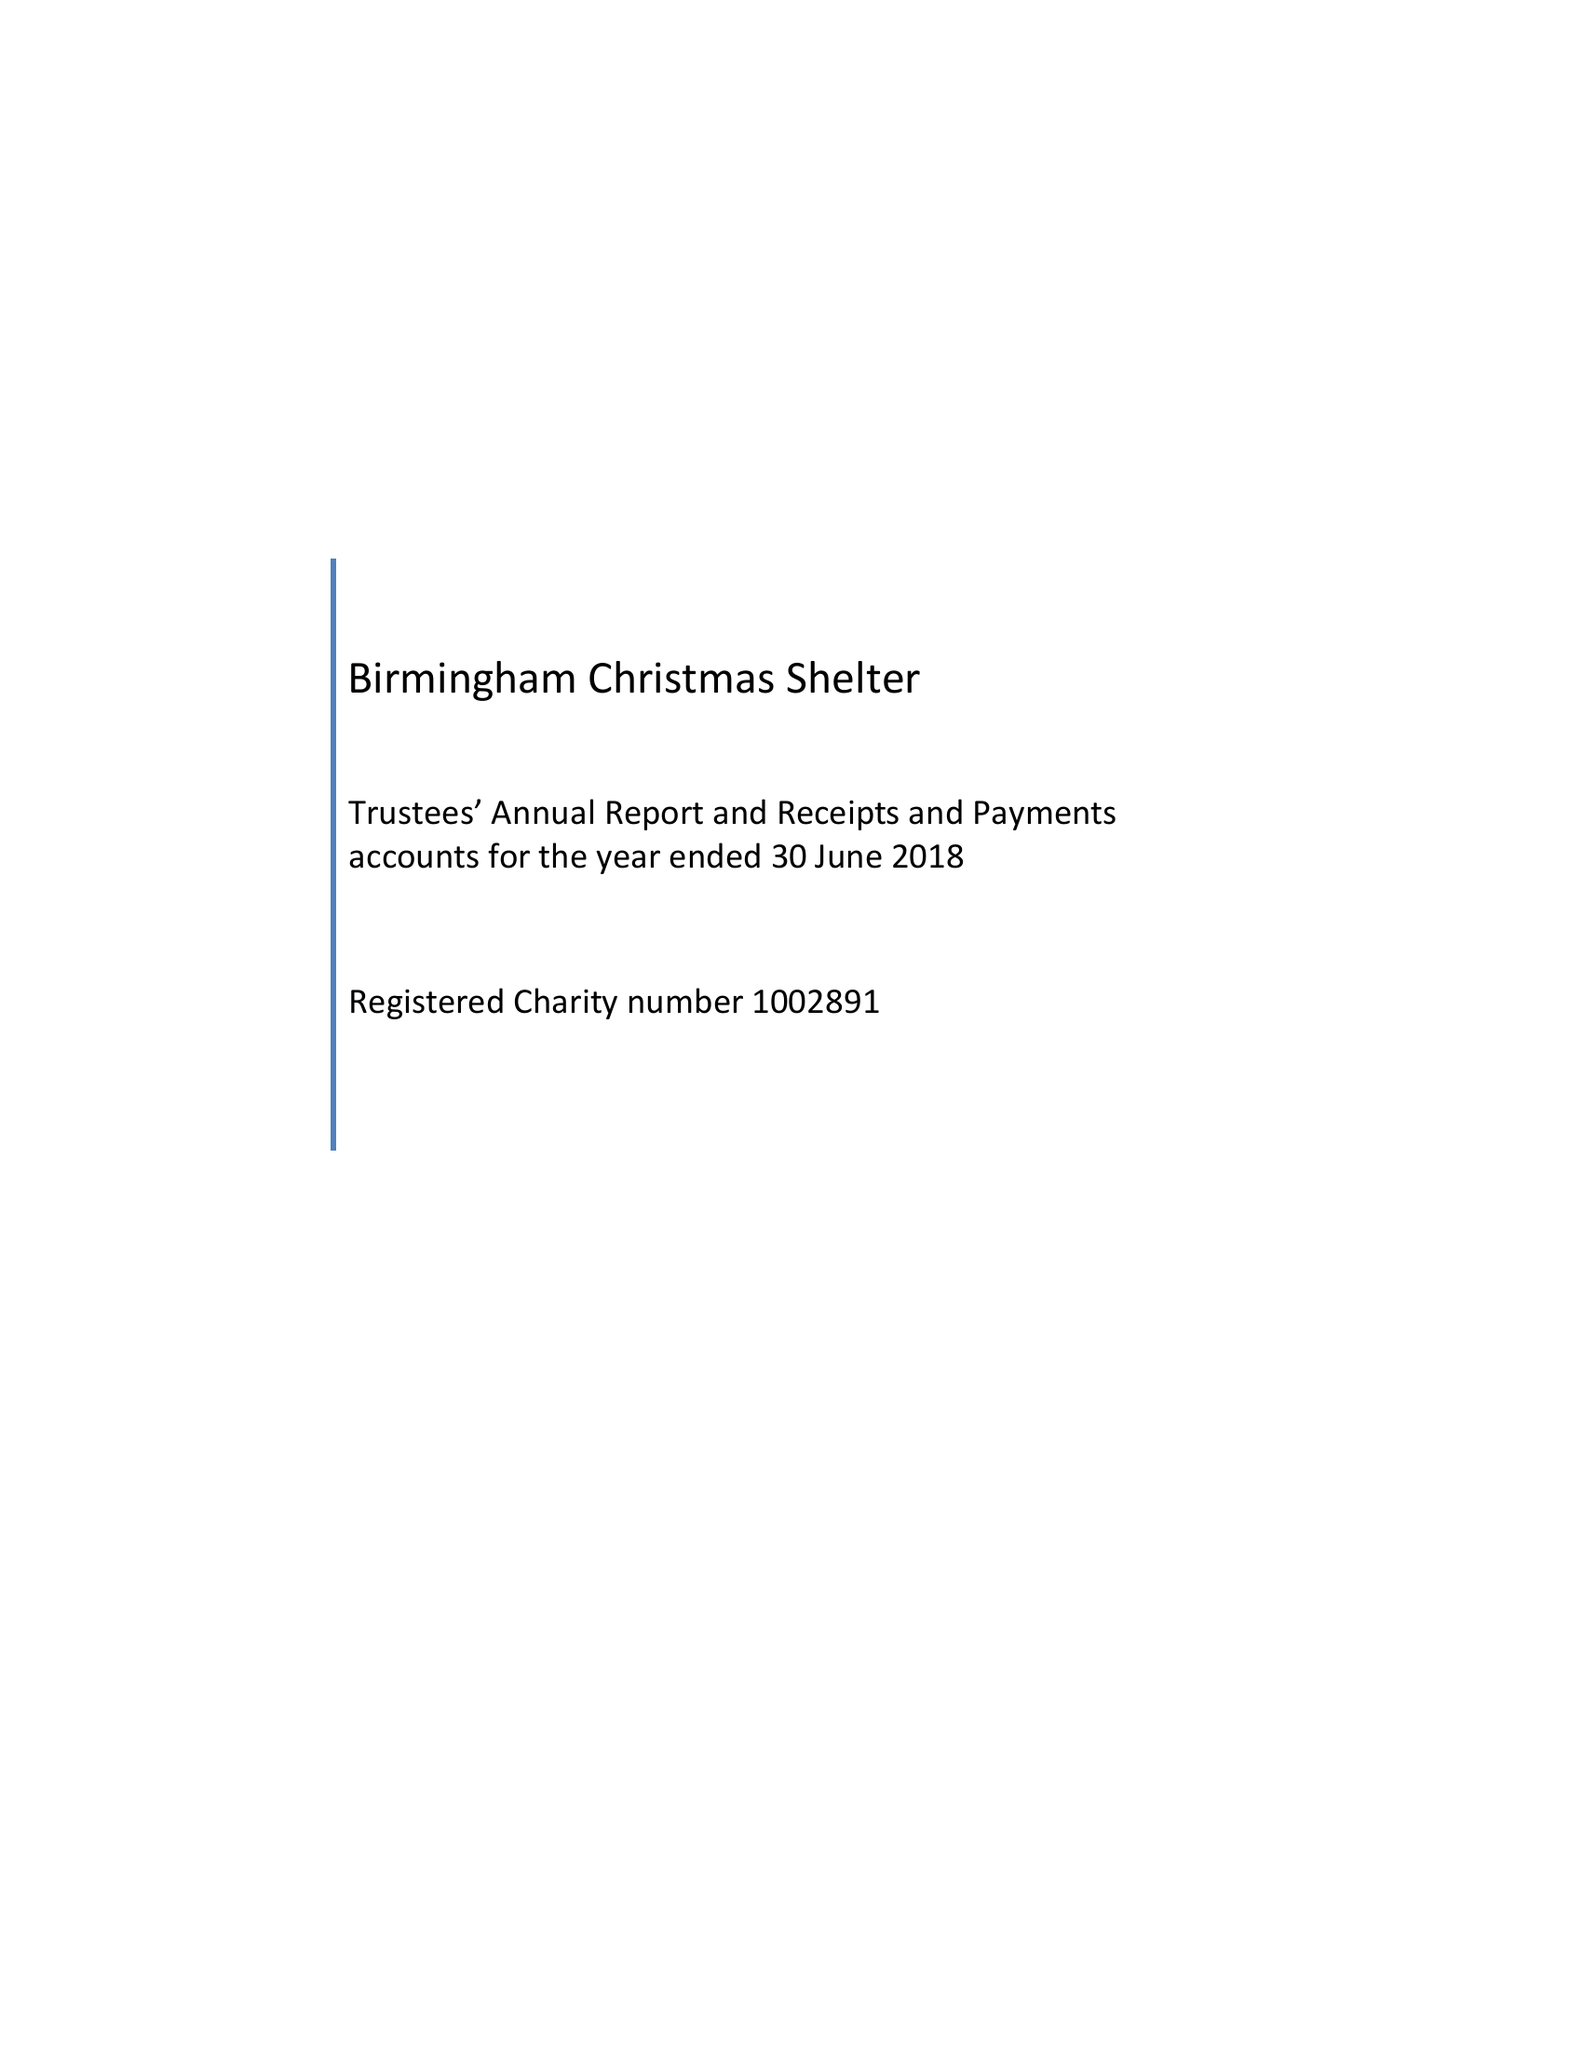What is the value for the address__postcode?
Answer the question using a single word or phrase. B13 3PS 